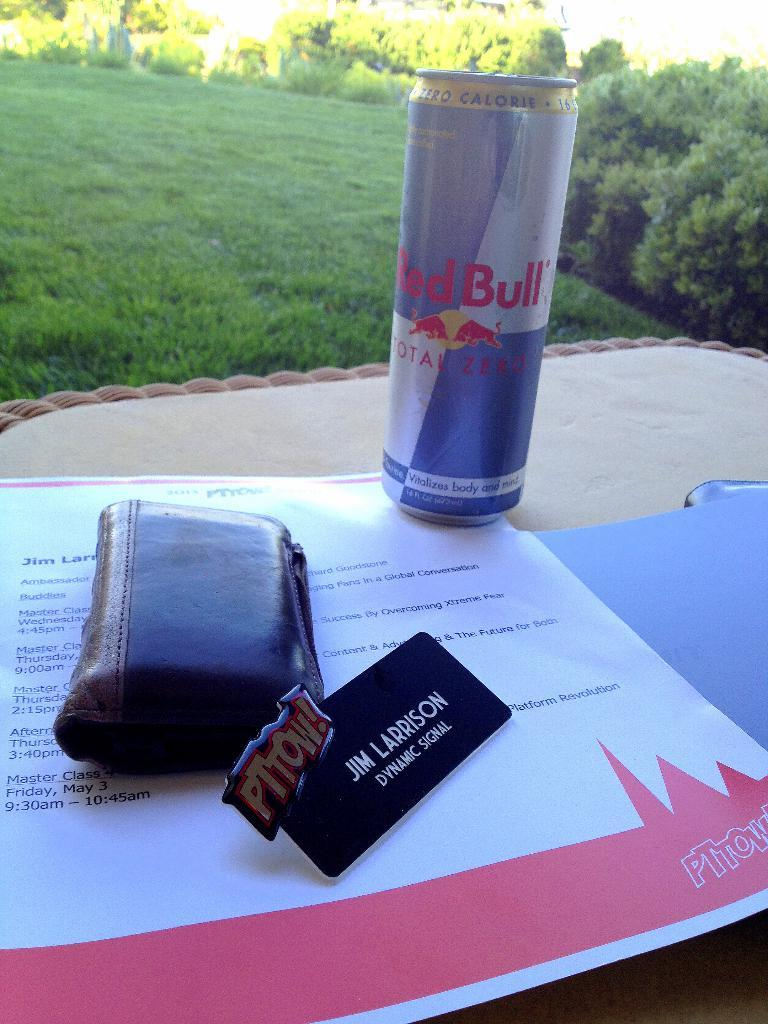What object made of metal can be seen in the image? There is a tin in the image. What object used for holding money and cards can be seen in the image? There is a wallet in the image. What type of material is the surface on which the papers are placed? The surface is cream-colored. What type of vegetation is visible in the background of the image? Trees and grass are visible in the background of the image. What color is the grass in the image? The grass is green in color. What type of thread is used to sew the pin onto the tin in the image? There is no thread or pin present in the image; it only features a tin, a wallet, papers, and a natural setting. 